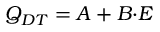<formula> <loc_0><loc_0><loc_500><loc_500>Q _ { D T } = A + B { \cdot } E</formula> 